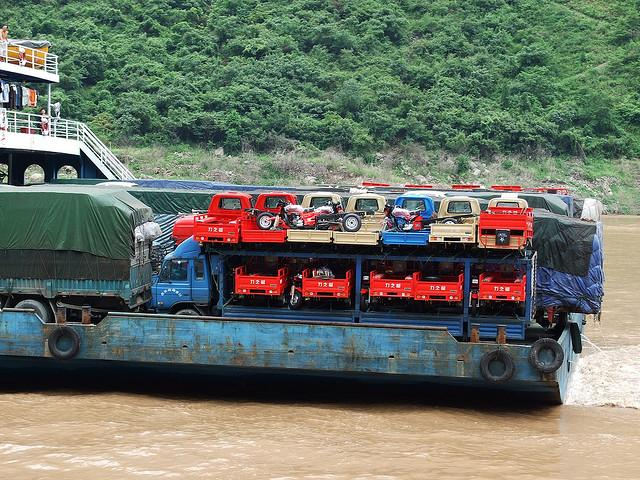Why are all the trucks in back of the boat?

Choices:
A) stole them
B) hauling them
C) part boat
D) hiding them hauling them 